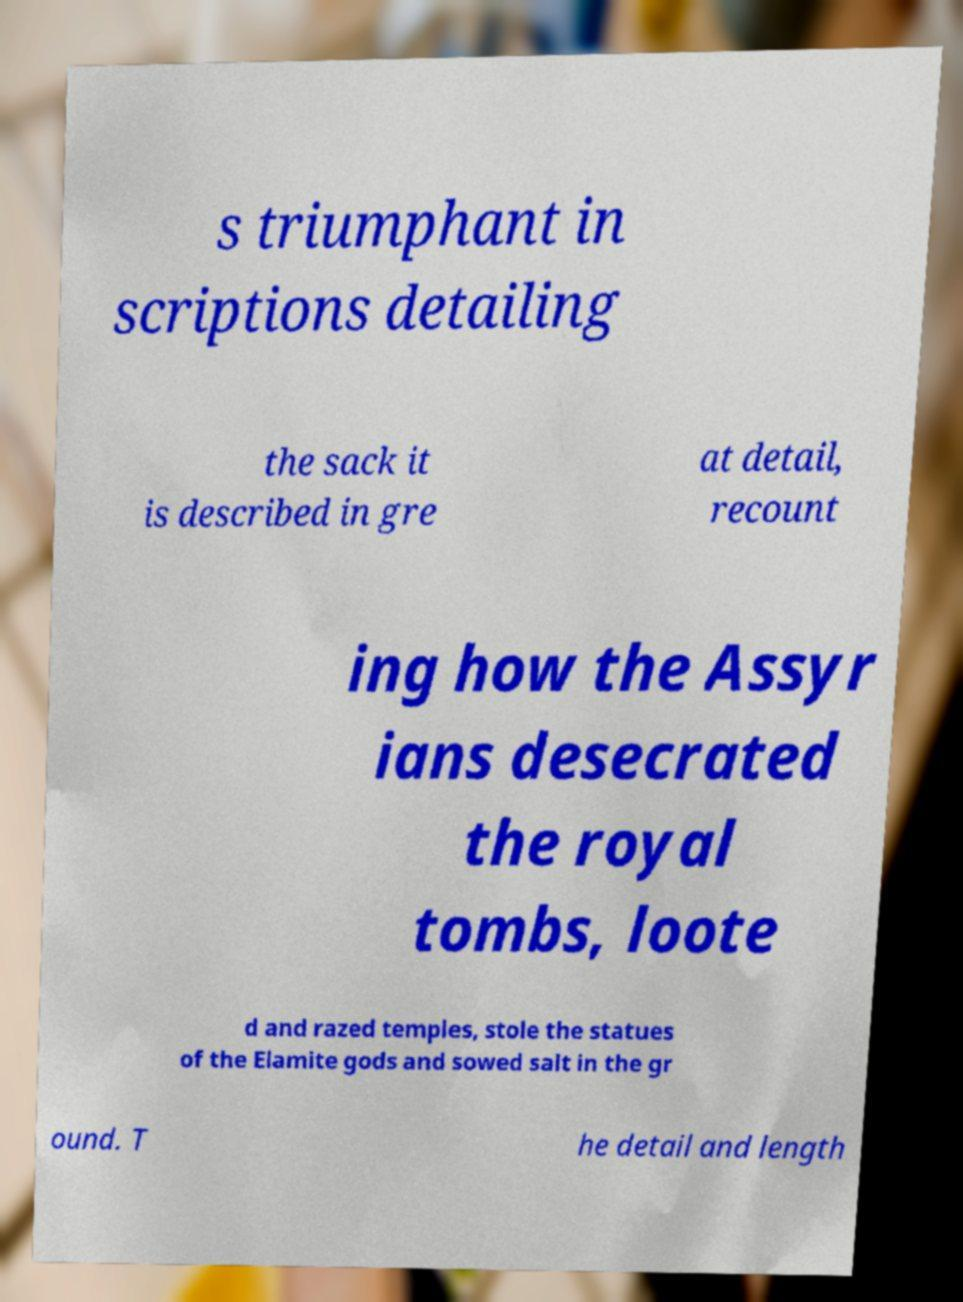Can you read and provide the text displayed in the image?This photo seems to have some interesting text. Can you extract and type it out for me? s triumphant in scriptions detailing the sack it is described in gre at detail, recount ing how the Assyr ians desecrated the royal tombs, loote d and razed temples, stole the statues of the Elamite gods and sowed salt in the gr ound. T he detail and length 